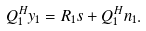<formula> <loc_0><loc_0><loc_500><loc_500>Q _ { 1 } ^ { H } y _ { 1 } = R _ { 1 } s + Q ^ { H } _ { 1 } n _ { 1 } .</formula> 